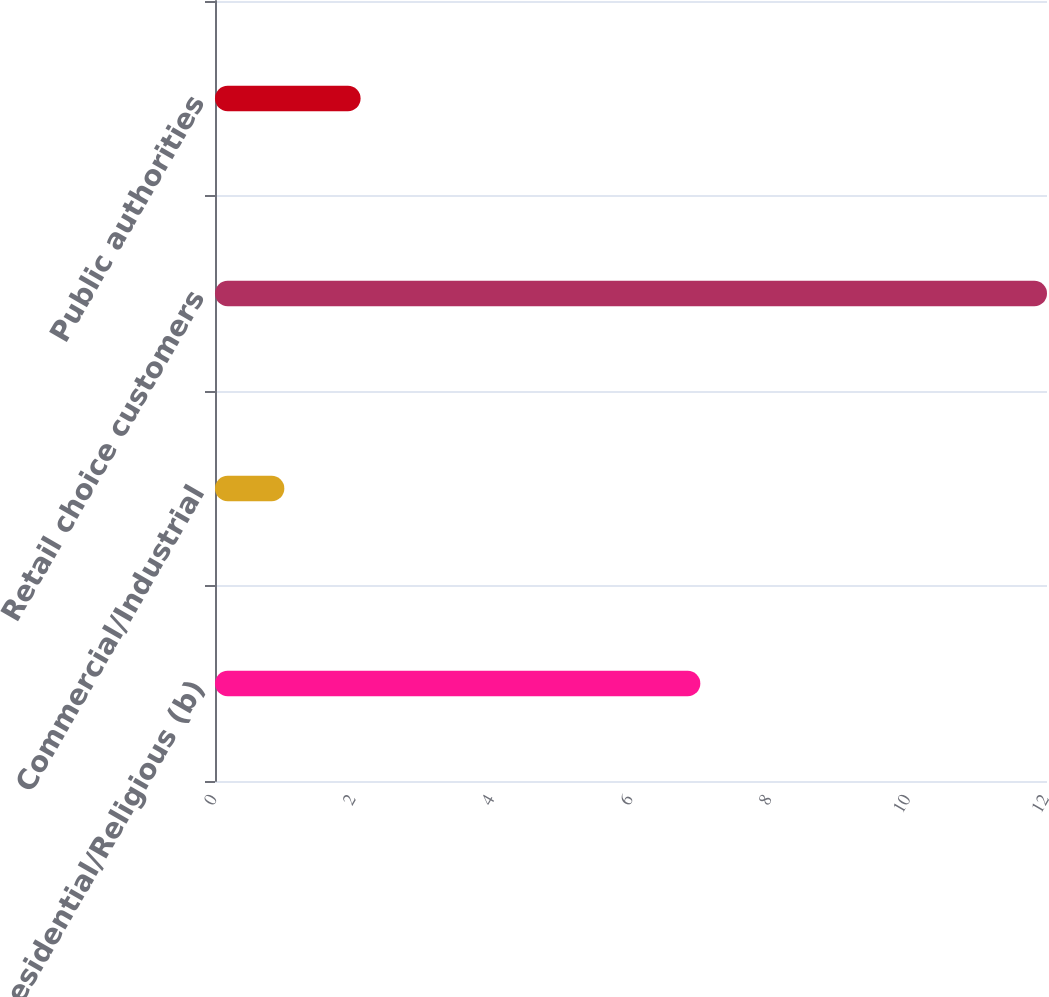<chart> <loc_0><loc_0><loc_500><loc_500><bar_chart><fcel>Residential/Religious (b)<fcel>Commercial/Industrial<fcel>Retail choice customers<fcel>Public authorities<nl><fcel>7<fcel>1<fcel>12<fcel>2.1<nl></chart> 